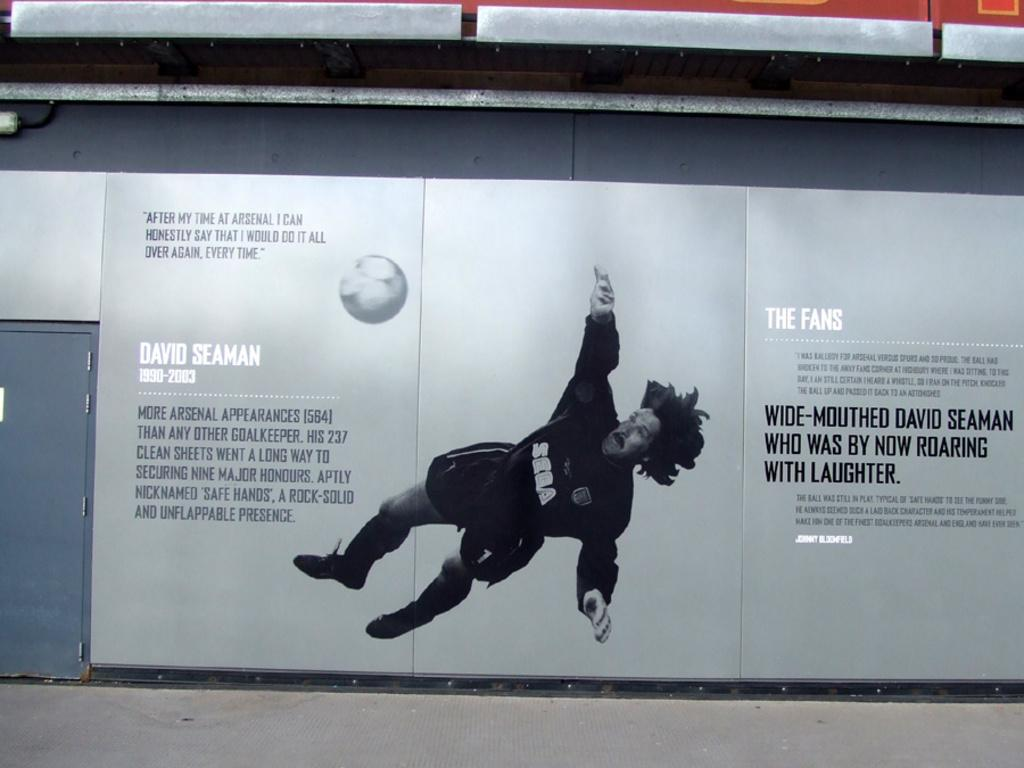What is featured on the wall in the image? There is a wall poster in the image. Who is present in the image? There is a man standing in the image. What object can be seen in the image? There is a ball in the image. Where is the text located in the image? The text is on the left side of the image. What architectural feature is visible in the image? There is a door in the image. What type of company is depicted on the ship in the image? There is no ship or company present in the image. What kind of cheese is being served on the table in the image? There is no cheese or table present in the image. 